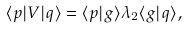Convert formula to latex. <formula><loc_0><loc_0><loc_500><loc_500>\langle { p } | V | { q } \rangle = \langle { p } | g \rangle \lambda _ { 2 } \langle g | { q } \rangle ,</formula> 